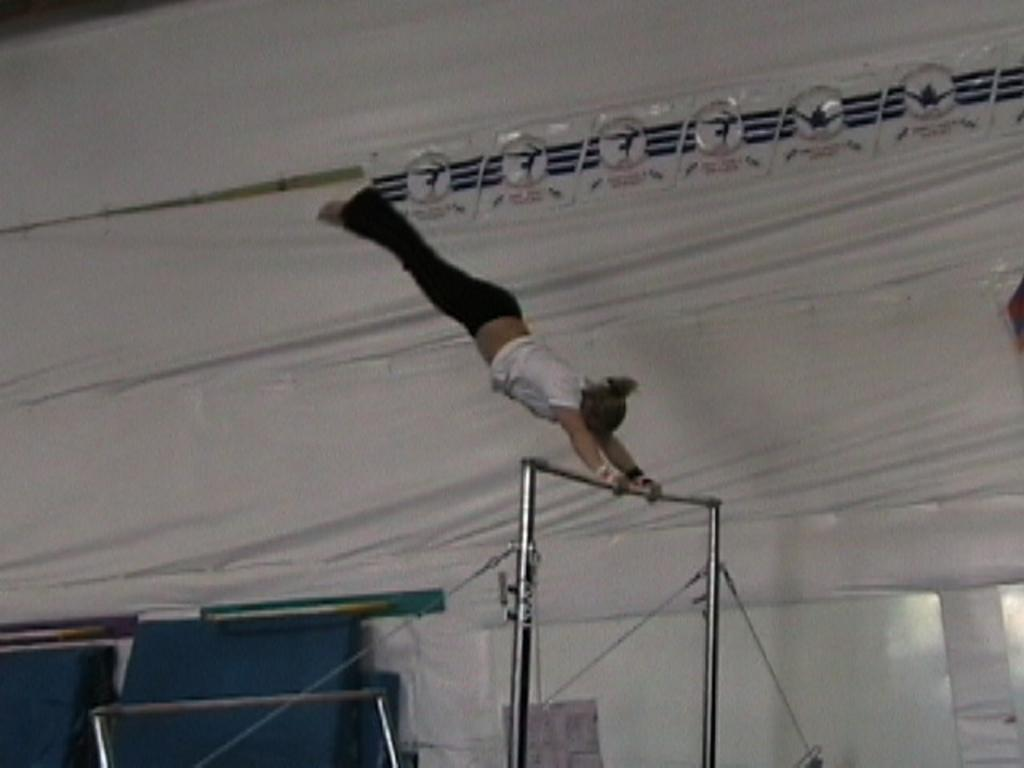What is the main subject of the image? There is a person in the image. What is the person doing in the image? The person is performing gymnastics. What object is the person holding in the image? The person is holding a rod. What color is the background of the image? The background of the image is white. What type of pet can be seen playing with a potato in the image? There is no pet or potato present in the image; it features a person performing gymnastics with a rod. Can you tell me how many bats are flying in the background of the image? There are no bats visible in the image, as the background is white. 